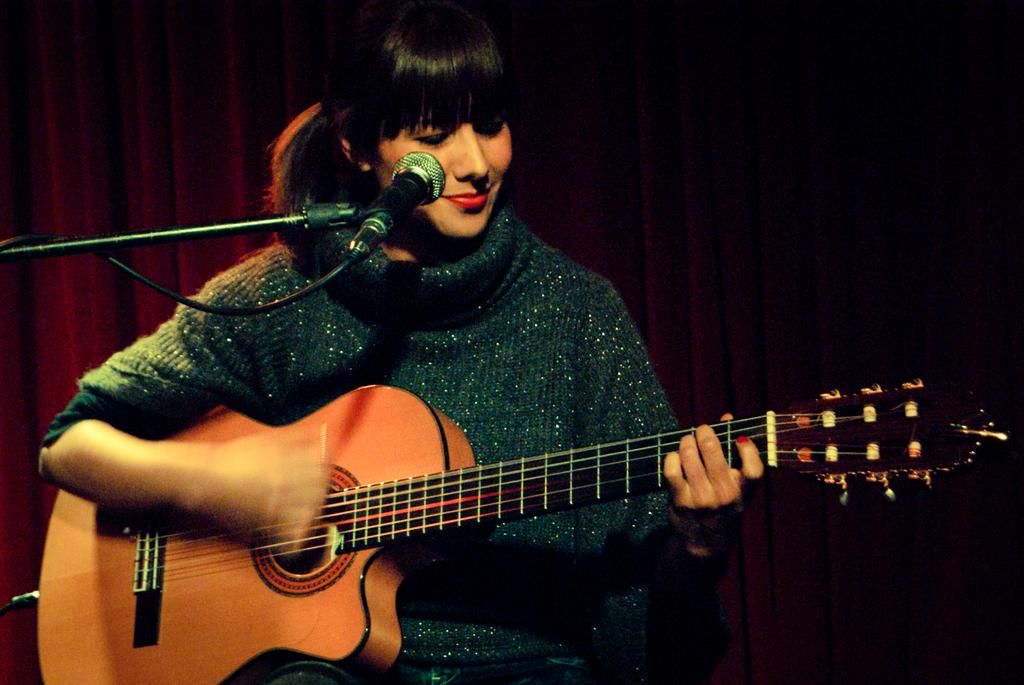Who is present in the image? There is a woman in the image. What is the woman doing in the image? The woman is sitting in the image. What is the woman holding in the image? The woman is holding a music instrument in the image. What is the color of the music instrument? The music instrument is yellow in color. What can be seen in the background of the image? There is a red color curtain in the background of the image. Can you tell me the grade of the frog in the image? There is no frog present in the image, so it is not possible to determine its grade. 